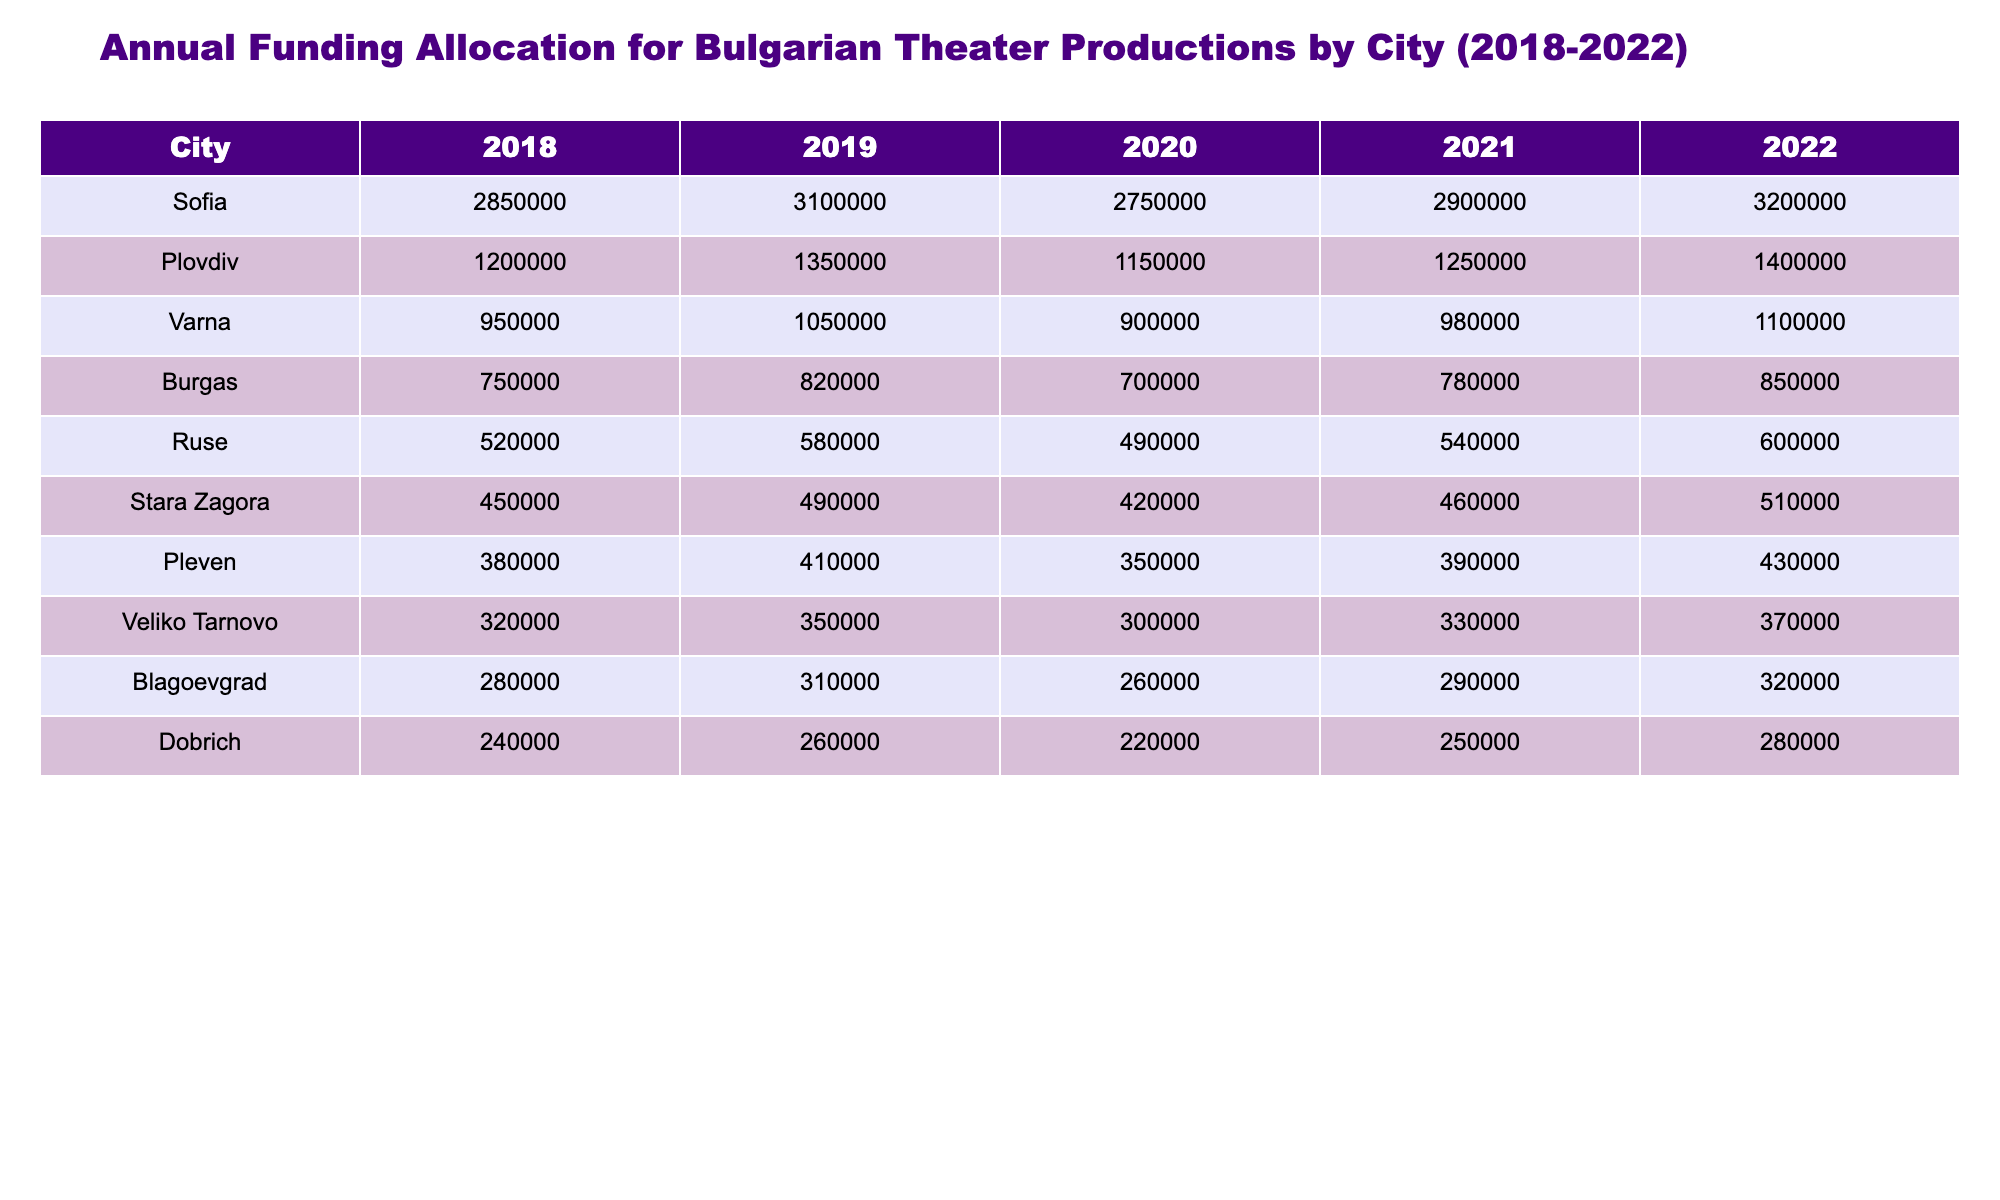What was the funding allocation for Varna in 2021? The table shows that the funding allocation for Varna in 2021 is 980,000.
Answer: 980,000 Which city received the highest funding in 2022? By comparing the values in the 2022 column, Sofia has the highest funding allocation of 3,200,000, which is greater than any other city.
Answer: Sofia What is the total funding for Plovdiv from 2018 to 2022? The total funding for Plovdiv can be calculated by adding up the allocations for the years 2018 (1,200,000), 2019 (1,350,000), 2020 (1,150,000), 2021 (1,250,000), and 2022 (1,400,000), resulting in a total of 6,400,000.
Answer: 6,400,000 Did Burgas receive more funding in 2020 than in 2019? The table shows that Burgas received 700,000 in 2020 and 820,000 in 2019. Therefore, the statement is false as 700,000 is less than 820,000.
Answer: No What was the average funding for Ruse over these five years? To calculate the average funding for Ruse, add the allocations for each year: 520,000 + 580,000 + 490,000 + 540,000 + 600,000 = 2,730,000. Then divide this total by 5 (the number of years), resulting in an average of 546,000.
Answer: 546,000 Which two cities had the closest funding allocations in 2022? In 2022, Sofia had 3,200,000 and Plovdiv had 1,400,000, which are not close. When comparing the other cities, Veliko Tarnovo at 370,000 and Blagoevgrad at 320,000 are the two cities with the closest allocations of 370,000 and 320,000.
Answer: Veliko Tarnovo and Blagoevgrad What was the overall trend in funding for Sofia from 2018 to 2022? By observing the funding values for Sofia, they show an increase from 2,850,000 in 2018 to 3,200,000 in 2022, indicating a general upward trend over these years.
Answer: Increasing Which city had the median funding allocation in 2020? First, we find the funding values for all cities in 2020, then sort them: Ruse (490,000), Burgas (700,000), Varna (900,000), and so forth. The median city funding (middle value when sorted) corresponds to Pleven, which received 350,000.
Answer: Pleven In which year did Dobrich have the least funding allocation? According to the table, Dobrich had the least funding allocation in 2020 with an amount of 220,000, as this is smaller than in any other year listed.
Answer: 2020 How much more funding did Sofia receive compared to the next highest city in 2021? In 2021, Sofia received 2,900,000, and Plovdiv received 1,250,000. The difference between these amounts is 2,900,000 - 1,250,000 = 1,650,000, indicating that Sofia received significantly more funding than Plovdiv.
Answer: 1,650,000 